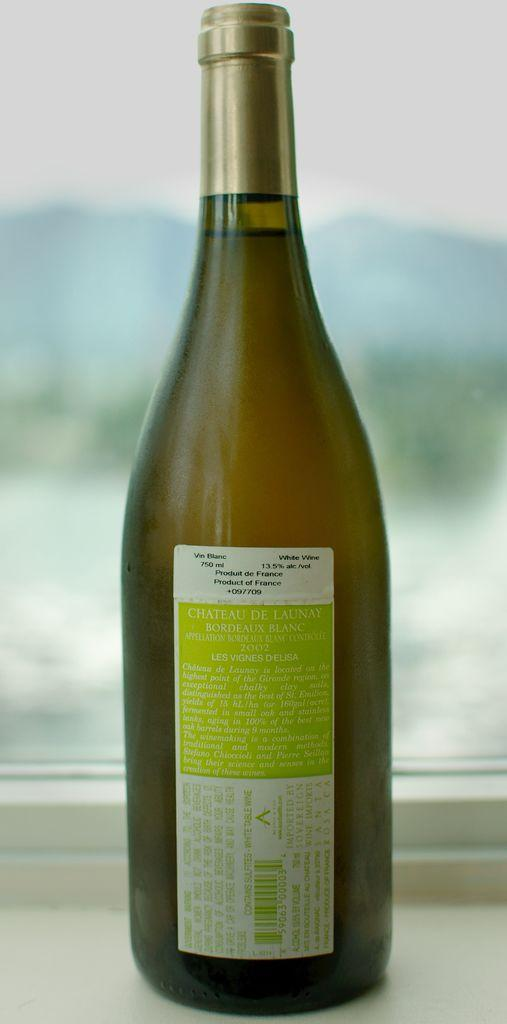<image>
Render a clear and concise summary of the photo. The label on a bottle of wine indicates that it is a product of France. 